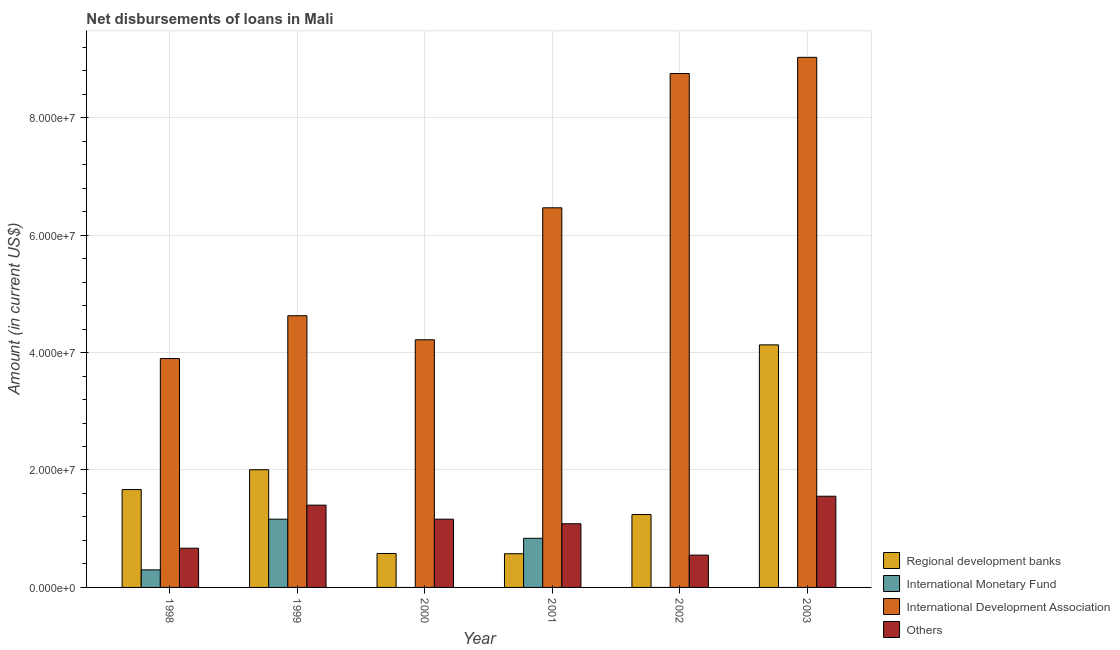How many different coloured bars are there?
Your answer should be very brief. 4. How many groups of bars are there?
Your answer should be compact. 6. Are the number of bars on each tick of the X-axis equal?
Give a very brief answer. No. How many bars are there on the 4th tick from the right?
Provide a succinct answer. 3. In how many cases, is the number of bars for a given year not equal to the number of legend labels?
Ensure brevity in your answer.  3. What is the amount of loan disimbursed by regional development banks in 2003?
Your response must be concise. 4.13e+07. Across all years, what is the maximum amount of loan disimbursed by other organisations?
Provide a short and direct response. 1.55e+07. Across all years, what is the minimum amount of loan disimbursed by international monetary fund?
Your answer should be very brief. 0. In which year was the amount of loan disimbursed by other organisations maximum?
Make the answer very short. 2003. What is the total amount of loan disimbursed by regional development banks in the graph?
Make the answer very short. 1.02e+08. What is the difference between the amount of loan disimbursed by regional development banks in 2000 and that in 2003?
Give a very brief answer. -3.55e+07. What is the difference between the amount of loan disimbursed by regional development banks in 2001 and the amount of loan disimbursed by other organisations in 2000?
Provide a short and direct response. -3.80e+04. What is the average amount of loan disimbursed by international development association per year?
Give a very brief answer. 6.16e+07. What is the ratio of the amount of loan disimbursed by regional development banks in 1998 to that in 1999?
Your response must be concise. 0.83. Is the difference between the amount of loan disimbursed by international monetary fund in 1998 and 1999 greater than the difference between the amount of loan disimbursed by international development association in 1998 and 1999?
Offer a terse response. No. What is the difference between the highest and the second highest amount of loan disimbursed by international development association?
Keep it short and to the point. 2.76e+06. What is the difference between the highest and the lowest amount of loan disimbursed by international monetary fund?
Provide a short and direct response. 1.16e+07. In how many years, is the amount of loan disimbursed by international monetary fund greater than the average amount of loan disimbursed by international monetary fund taken over all years?
Make the answer very short. 2. Is it the case that in every year, the sum of the amount of loan disimbursed by regional development banks and amount of loan disimbursed by international monetary fund is greater than the sum of amount of loan disimbursed by international development association and amount of loan disimbursed by other organisations?
Give a very brief answer. No. Is it the case that in every year, the sum of the amount of loan disimbursed by regional development banks and amount of loan disimbursed by international monetary fund is greater than the amount of loan disimbursed by international development association?
Provide a short and direct response. No. How many bars are there?
Ensure brevity in your answer.  21. Are all the bars in the graph horizontal?
Make the answer very short. No. How many years are there in the graph?
Keep it short and to the point. 6. What is the difference between two consecutive major ticks on the Y-axis?
Keep it short and to the point. 2.00e+07. Are the values on the major ticks of Y-axis written in scientific E-notation?
Give a very brief answer. Yes. Does the graph contain grids?
Your response must be concise. Yes. What is the title of the graph?
Give a very brief answer. Net disbursements of loans in Mali. What is the Amount (in current US$) of Regional development banks in 1998?
Provide a succinct answer. 1.67e+07. What is the Amount (in current US$) of International Monetary Fund in 1998?
Your response must be concise. 2.99e+06. What is the Amount (in current US$) of International Development Association in 1998?
Provide a short and direct response. 3.90e+07. What is the Amount (in current US$) of Others in 1998?
Your answer should be compact. 6.68e+06. What is the Amount (in current US$) of Regional development banks in 1999?
Offer a terse response. 2.00e+07. What is the Amount (in current US$) in International Monetary Fund in 1999?
Give a very brief answer. 1.16e+07. What is the Amount (in current US$) in International Development Association in 1999?
Your answer should be compact. 4.63e+07. What is the Amount (in current US$) of Others in 1999?
Give a very brief answer. 1.40e+07. What is the Amount (in current US$) in Regional development banks in 2000?
Your answer should be very brief. 5.78e+06. What is the Amount (in current US$) in International Monetary Fund in 2000?
Provide a short and direct response. 0. What is the Amount (in current US$) of International Development Association in 2000?
Give a very brief answer. 4.22e+07. What is the Amount (in current US$) of Others in 2000?
Your answer should be very brief. 1.16e+07. What is the Amount (in current US$) in Regional development banks in 2001?
Your response must be concise. 5.74e+06. What is the Amount (in current US$) of International Monetary Fund in 2001?
Offer a terse response. 8.37e+06. What is the Amount (in current US$) of International Development Association in 2001?
Your response must be concise. 6.46e+07. What is the Amount (in current US$) in Others in 2001?
Offer a very short reply. 1.08e+07. What is the Amount (in current US$) in Regional development banks in 2002?
Offer a very short reply. 1.24e+07. What is the Amount (in current US$) of International Development Association in 2002?
Make the answer very short. 8.75e+07. What is the Amount (in current US$) in Others in 2002?
Your answer should be compact. 5.50e+06. What is the Amount (in current US$) in Regional development banks in 2003?
Make the answer very short. 4.13e+07. What is the Amount (in current US$) of International Monetary Fund in 2003?
Provide a succinct answer. 0. What is the Amount (in current US$) of International Development Association in 2003?
Provide a succinct answer. 9.03e+07. What is the Amount (in current US$) of Others in 2003?
Provide a succinct answer. 1.55e+07. Across all years, what is the maximum Amount (in current US$) in Regional development banks?
Your response must be concise. 4.13e+07. Across all years, what is the maximum Amount (in current US$) of International Monetary Fund?
Your response must be concise. 1.16e+07. Across all years, what is the maximum Amount (in current US$) in International Development Association?
Ensure brevity in your answer.  9.03e+07. Across all years, what is the maximum Amount (in current US$) in Others?
Keep it short and to the point. 1.55e+07. Across all years, what is the minimum Amount (in current US$) in Regional development banks?
Your answer should be compact. 5.74e+06. Across all years, what is the minimum Amount (in current US$) of International Monetary Fund?
Offer a terse response. 0. Across all years, what is the minimum Amount (in current US$) of International Development Association?
Provide a short and direct response. 3.90e+07. Across all years, what is the minimum Amount (in current US$) of Others?
Offer a very short reply. 5.50e+06. What is the total Amount (in current US$) of Regional development banks in the graph?
Keep it short and to the point. 1.02e+08. What is the total Amount (in current US$) in International Monetary Fund in the graph?
Make the answer very short. 2.30e+07. What is the total Amount (in current US$) in International Development Association in the graph?
Ensure brevity in your answer.  3.70e+08. What is the total Amount (in current US$) in Others in the graph?
Your answer should be compact. 6.42e+07. What is the difference between the Amount (in current US$) of Regional development banks in 1998 and that in 1999?
Your answer should be very brief. -3.38e+06. What is the difference between the Amount (in current US$) of International Monetary Fund in 1998 and that in 1999?
Offer a terse response. -8.63e+06. What is the difference between the Amount (in current US$) of International Development Association in 1998 and that in 1999?
Provide a succinct answer. -7.29e+06. What is the difference between the Amount (in current US$) in Others in 1998 and that in 1999?
Provide a succinct answer. -7.33e+06. What is the difference between the Amount (in current US$) of Regional development banks in 1998 and that in 2000?
Offer a very short reply. 1.09e+07. What is the difference between the Amount (in current US$) in International Development Association in 1998 and that in 2000?
Your answer should be compact. -3.20e+06. What is the difference between the Amount (in current US$) in Others in 1998 and that in 2000?
Your answer should be compact. -4.94e+06. What is the difference between the Amount (in current US$) in Regional development banks in 1998 and that in 2001?
Keep it short and to the point. 1.09e+07. What is the difference between the Amount (in current US$) of International Monetary Fund in 1998 and that in 2001?
Provide a short and direct response. -5.37e+06. What is the difference between the Amount (in current US$) of International Development Association in 1998 and that in 2001?
Make the answer very short. -2.57e+07. What is the difference between the Amount (in current US$) of Others in 1998 and that in 2001?
Offer a very short reply. -4.16e+06. What is the difference between the Amount (in current US$) of Regional development banks in 1998 and that in 2002?
Your response must be concise. 4.25e+06. What is the difference between the Amount (in current US$) of International Development Association in 1998 and that in 2002?
Give a very brief answer. -4.85e+07. What is the difference between the Amount (in current US$) of Others in 1998 and that in 2002?
Your answer should be very brief. 1.18e+06. What is the difference between the Amount (in current US$) of Regional development banks in 1998 and that in 2003?
Make the answer very short. -2.46e+07. What is the difference between the Amount (in current US$) of International Development Association in 1998 and that in 2003?
Your answer should be very brief. -5.13e+07. What is the difference between the Amount (in current US$) of Others in 1998 and that in 2003?
Provide a succinct answer. -8.85e+06. What is the difference between the Amount (in current US$) in Regional development banks in 1999 and that in 2000?
Make the answer very short. 1.43e+07. What is the difference between the Amount (in current US$) of International Development Association in 1999 and that in 2000?
Make the answer very short. 4.10e+06. What is the difference between the Amount (in current US$) of Others in 1999 and that in 2000?
Your response must be concise. 2.39e+06. What is the difference between the Amount (in current US$) of Regional development banks in 1999 and that in 2001?
Provide a short and direct response. 1.43e+07. What is the difference between the Amount (in current US$) of International Monetary Fund in 1999 and that in 2001?
Offer a terse response. 3.26e+06. What is the difference between the Amount (in current US$) of International Development Association in 1999 and that in 2001?
Your answer should be compact. -1.84e+07. What is the difference between the Amount (in current US$) of Others in 1999 and that in 2001?
Keep it short and to the point. 3.17e+06. What is the difference between the Amount (in current US$) in Regional development banks in 1999 and that in 2002?
Keep it short and to the point. 7.63e+06. What is the difference between the Amount (in current US$) in International Development Association in 1999 and that in 2002?
Your answer should be very brief. -4.12e+07. What is the difference between the Amount (in current US$) of Others in 1999 and that in 2002?
Offer a terse response. 8.51e+06. What is the difference between the Amount (in current US$) of Regional development banks in 1999 and that in 2003?
Keep it short and to the point. -2.13e+07. What is the difference between the Amount (in current US$) of International Development Association in 1999 and that in 2003?
Make the answer very short. -4.40e+07. What is the difference between the Amount (in current US$) of Others in 1999 and that in 2003?
Your answer should be compact. -1.52e+06. What is the difference between the Amount (in current US$) of Regional development banks in 2000 and that in 2001?
Offer a terse response. 3.80e+04. What is the difference between the Amount (in current US$) of International Development Association in 2000 and that in 2001?
Give a very brief answer. -2.25e+07. What is the difference between the Amount (in current US$) in Others in 2000 and that in 2001?
Provide a short and direct response. 7.78e+05. What is the difference between the Amount (in current US$) of Regional development banks in 2000 and that in 2002?
Provide a succinct answer. -6.64e+06. What is the difference between the Amount (in current US$) of International Development Association in 2000 and that in 2002?
Give a very brief answer. -4.53e+07. What is the difference between the Amount (in current US$) of Others in 2000 and that in 2002?
Your response must be concise. 6.12e+06. What is the difference between the Amount (in current US$) in Regional development banks in 2000 and that in 2003?
Provide a succinct answer. -3.55e+07. What is the difference between the Amount (in current US$) of International Development Association in 2000 and that in 2003?
Provide a short and direct response. -4.81e+07. What is the difference between the Amount (in current US$) of Others in 2000 and that in 2003?
Your response must be concise. -3.91e+06. What is the difference between the Amount (in current US$) in Regional development banks in 2001 and that in 2002?
Give a very brief answer. -6.68e+06. What is the difference between the Amount (in current US$) in International Development Association in 2001 and that in 2002?
Your answer should be very brief. -2.29e+07. What is the difference between the Amount (in current US$) in Others in 2001 and that in 2002?
Ensure brevity in your answer.  5.34e+06. What is the difference between the Amount (in current US$) of Regional development banks in 2001 and that in 2003?
Ensure brevity in your answer.  -3.56e+07. What is the difference between the Amount (in current US$) in International Development Association in 2001 and that in 2003?
Keep it short and to the point. -2.56e+07. What is the difference between the Amount (in current US$) in Others in 2001 and that in 2003?
Keep it short and to the point. -4.69e+06. What is the difference between the Amount (in current US$) in Regional development banks in 2002 and that in 2003?
Provide a succinct answer. -2.89e+07. What is the difference between the Amount (in current US$) of International Development Association in 2002 and that in 2003?
Keep it short and to the point. -2.76e+06. What is the difference between the Amount (in current US$) in Others in 2002 and that in 2003?
Keep it short and to the point. -1.00e+07. What is the difference between the Amount (in current US$) in Regional development banks in 1998 and the Amount (in current US$) in International Monetary Fund in 1999?
Ensure brevity in your answer.  5.04e+06. What is the difference between the Amount (in current US$) in Regional development banks in 1998 and the Amount (in current US$) in International Development Association in 1999?
Offer a terse response. -2.96e+07. What is the difference between the Amount (in current US$) in Regional development banks in 1998 and the Amount (in current US$) in Others in 1999?
Provide a succinct answer. 2.65e+06. What is the difference between the Amount (in current US$) of International Monetary Fund in 1998 and the Amount (in current US$) of International Development Association in 1999?
Your answer should be compact. -4.33e+07. What is the difference between the Amount (in current US$) in International Monetary Fund in 1998 and the Amount (in current US$) in Others in 1999?
Give a very brief answer. -1.10e+07. What is the difference between the Amount (in current US$) in International Development Association in 1998 and the Amount (in current US$) in Others in 1999?
Your answer should be very brief. 2.50e+07. What is the difference between the Amount (in current US$) of Regional development banks in 1998 and the Amount (in current US$) of International Development Association in 2000?
Your response must be concise. -2.55e+07. What is the difference between the Amount (in current US$) in Regional development banks in 1998 and the Amount (in current US$) in Others in 2000?
Your response must be concise. 5.04e+06. What is the difference between the Amount (in current US$) of International Monetary Fund in 1998 and the Amount (in current US$) of International Development Association in 2000?
Your answer should be very brief. -3.92e+07. What is the difference between the Amount (in current US$) of International Monetary Fund in 1998 and the Amount (in current US$) of Others in 2000?
Provide a succinct answer. -8.63e+06. What is the difference between the Amount (in current US$) in International Development Association in 1998 and the Amount (in current US$) in Others in 2000?
Keep it short and to the point. 2.74e+07. What is the difference between the Amount (in current US$) of Regional development banks in 1998 and the Amount (in current US$) of International Monetary Fund in 2001?
Ensure brevity in your answer.  8.30e+06. What is the difference between the Amount (in current US$) in Regional development banks in 1998 and the Amount (in current US$) in International Development Association in 2001?
Your response must be concise. -4.80e+07. What is the difference between the Amount (in current US$) of Regional development banks in 1998 and the Amount (in current US$) of Others in 2001?
Give a very brief answer. 5.82e+06. What is the difference between the Amount (in current US$) in International Monetary Fund in 1998 and the Amount (in current US$) in International Development Association in 2001?
Make the answer very short. -6.17e+07. What is the difference between the Amount (in current US$) in International Monetary Fund in 1998 and the Amount (in current US$) in Others in 2001?
Your answer should be very brief. -7.85e+06. What is the difference between the Amount (in current US$) in International Development Association in 1998 and the Amount (in current US$) in Others in 2001?
Keep it short and to the point. 2.81e+07. What is the difference between the Amount (in current US$) in Regional development banks in 1998 and the Amount (in current US$) in International Development Association in 2002?
Your response must be concise. -7.08e+07. What is the difference between the Amount (in current US$) of Regional development banks in 1998 and the Amount (in current US$) of Others in 2002?
Ensure brevity in your answer.  1.12e+07. What is the difference between the Amount (in current US$) in International Monetary Fund in 1998 and the Amount (in current US$) in International Development Association in 2002?
Provide a succinct answer. -8.45e+07. What is the difference between the Amount (in current US$) in International Monetary Fund in 1998 and the Amount (in current US$) in Others in 2002?
Your answer should be very brief. -2.51e+06. What is the difference between the Amount (in current US$) in International Development Association in 1998 and the Amount (in current US$) in Others in 2002?
Your answer should be compact. 3.35e+07. What is the difference between the Amount (in current US$) of Regional development banks in 1998 and the Amount (in current US$) of International Development Association in 2003?
Provide a succinct answer. -7.36e+07. What is the difference between the Amount (in current US$) in Regional development banks in 1998 and the Amount (in current US$) in Others in 2003?
Your answer should be compact. 1.14e+06. What is the difference between the Amount (in current US$) of International Monetary Fund in 1998 and the Amount (in current US$) of International Development Association in 2003?
Ensure brevity in your answer.  -8.73e+07. What is the difference between the Amount (in current US$) in International Monetary Fund in 1998 and the Amount (in current US$) in Others in 2003?
Give a very brief answer. -1.25e+07. What is the difference between the Amount (in current US$) of International Development Association in 1998 and the Amount (in current US$) of Others in 2003?
Give a very brief answer. 2.34e+07. What is the difference between the Amount (in current US$) of Regional development banks in 1999 and the Amount (in current US$) of International Development Association in 2000?
Provide a succinct answer. -2.21e+07. What is the difference between the Amount (in current US$) of Regional development banks in 1999 and the Amount (in current US$) of Others in 2000?
Provide a short and direct response. 8.42e+06. What is the difference between the Amount (in current US$) in International Monetary Fund in 1999 and the Amount (in current US$) in International Development Association in 2000?
Keep it short and to the point. -3.06e+07. What is the difference between the Amount (in current US$) in International Development Association in 1999 and the Amount (in current US$) in Others in 2000?
Give a very brief answer. 3.46e+07. What is the difference between the Amount (in current US$) of Regional development banks in 1999 and the Amount (in current US$) of International Monetary Fund in 2001?
Give a very brief answer. 1.17e+07. What is the difference between the Amount (in current US$) of Regional development banks in 1999 and the Amount (in current US$) of International Development Association in 2001?
Your answer should be very brief. -4.46e+07. What is the difference between the Amount (in current US$) in Regional development banks in 1999 and the Amount (in current US$) in Others in 2001?
Ensure brevity in your answer.  9.20e+06. What is the difference between the Amount (in current US$) in International Monetary Fund in 1999 and the Amount (in current US$) in International Development Association in 2001?
Make the answer very short. -5.30e+07. What is the difference between the Amount (in current US$) in International Monetary Fund in 1999 and the Amount (in current US$) in Others in 2001?
Provide a succinct answer. 7.80e+05. What is the difference between the Amount (in current US$) of International Development Association in 1999 and the Amount (in current US$) of Others in 2001?
Provide a short and direct response. 3.54e+07. What is the difference between the Amount (in current US$) in Regional development banks in 1999 and the Amount (in current US$) in International Development Association in 2002?
Ensure brevity in your answer.  -6.75e+07. What is the difference between the Amount (in current US$) in Regional development banks in 1999 and the Amount (in current US$) in Others in 2002?
Your answer should be very brief. 1.45e+07. What is the difference between the Amount (in current US$) in International Monetary Fund in 1999 and the Amount (in current US$) in International Development Association in 2002?
Keep it short and to the point. -7.59e+07. What is the difference between the Amount (in current US$) of International Monetary Fund in 1999 and the Amount (in current US$) of Others in 2002?
Your response must be concise. 6.12e+06. What is the difference between the Amount (in current US$) of International Development Association in 1999 and the Amount (in current US$) of Others in 2002?
Your response must be concise. 4.08e+07. What is the difference between the Amount (in current US$) in Regional development banks in 1999 and the Amount (in current US$) in International Development Association in 2003?
Make the answer very short. -7.02e+07. What is the difference between the Amount (in current US$) in Regional development banks in 1999 and the Amount (in current US$) in Others in 2003?
Make the answer very short. 4.51e+06. What is the difference between the Amount (in current US$) of International Monetary Fund in 1999 and the Amount (in current US$) of International Development Association in 2003?
Your answer should be compact. -7.86e+07. What is the difference between the Amount (in current US$) in International Monetary Fund in 1999 and the Amount (in current US$) in Others in 2003?
Your answer should be compact. -3.91e+06. What is the difference between the Amount (in current US$) of International Development Association in 1999 and the Amount (in current US$) of Others in 2003?
Your answer should be compact. 3.07e+07. What is the difference between the Amount (in current US$) in Regional development banks in 2000 and the Amount (in current US$) in International Monetary Fund in 2001?
Your response must be concise. -2.59e+06. What is the difference between the Amount (in current US$) in Regional development banks in 2000 and the Amount (in current US$) in International Development Association in 2001?
Offer a terse response. -5.89e+07. What is the difference between the Amount (in current US$) in Regional development banks in 2000 and the Amount (in current US$) in Others in 2001?
Your answer should be compact. -5.07e+06. What is the difference between the Amount (in current US$) of International Development Association in 2000 and the Amount (in current US$) of Others in 2001?
Keep it short and to the point. 3.13e+07. What is the difference between the Amount (in current US$) of Regional development banks in 2000 and the Amount (in current US$) of International Development Association in 2002?
Make the answer very short. -8.17e+07. What is the difference between the Amount (in current US$) of Regional development banks in 2000 and the Amount (in current US$) of Others in 2002?
Provide a succinct answer. 2.74e+05. What is the difference between the Amount (in current US$) in International Development Association in 2000 and the Amount (in current US$) in Others in 2002?
Your answer should be compact. 3.67e+07. What is the difference between the Amount (in current US$) in Regional development banks in 2000 and the Amount (in current US$) in International Development Association in 2003?
Keep it short and to the point. -8.45e+07. What is the difference between the Amount (in current US$) in Regional development banks in 2000 and the Amount (in current US$) in Others in 2003?
Your response must be concise. -9.76e+06. What is the difference between the Amount (in current US$) of International Development Association in 2000 and the Amount (in current US$) of Others in 2003?
Your response must be concise. 2.66e+07. What is the difference between the Amount (in current US$) of Regional development banks in 2001 and the Amount (in current US$) of International Development Association in 2002?
Offer a terse response. -8.18e+07. What is the difference between the Amount (in current US$) in Regional development banks in 2001 and the Amount (in current US$) in Others in 2002?
Keep it short and to the point. 2.36e+05. What is the difference between the Amount (in current US$) of International Monetary Fund in 2001 and the Amount (in current US$) of International Development Association in 2002?
Ensure brevity in your answer.  -7.91e+07. What is the difference between the Amount (in current US$) of International Monetary Fund in 2001 and the Amount (in current US$) of Others in 2002?
Offer a terse response. 2.87e+06. What is the difference between the Amount (in current US$) of International Development Association in 2001 and the Amount (in current US$) of Others in 2002?
Your answer should be very brief. 5.91e+07. What is the difference between the Amount (in current US$) in Regional development banks in 2001 and the Amount (in current US$) in International Development Association in 2003?
Provide a succinct answer. -8.45e+07. What is the difference between the Amount (in current US$) of Regional development banks in 2001 and the Amount (in current US$) of Others in 2003?
Give a very brief answer. -9.79e+06. What is the difference between the Amount (in current US$) in International Monetary Fund in 2001 and the Amount (in current US$) in International Development Association in 2003?
Your answer should be compact. -8.19e+07. What is the difference between the Amount (in current US$) in International Monetary Fund in 2001 and the Amount (in current US$) in Others in 2003?
Provide a succinct answer. -7.16e+06. What is the difference between the Amount (in current US$) of International Development Association in 2001 and the Amount (in current US$) of Others in 2003?
Keep it short and to the point. 4.91e+07. What is the difference between the Amount (in current US$) in Regional development banks in 2002 and the Amount (in current US$) in International Development Association in 2003?
Your answer should be compact. -7.79e+07. What is the difference between the Amount (in current US$) of Regional development banks in 2002 and the Amount (in current US$) of Others in 2003?
Provide a short and direct response. -3.12e+06. What is the difference between the Amount (in current US$) of International Development Association in 2002 and the Amount (in current US$) of Others in 2003?
Provide a short and direct response. 7.20e+07. What is the average Amount (in current US$) of Regional development banks per year?
Offer a terse response. 1.70e+07. What is the average Amount (in current US$) of International Monetary Fund per year?
Your response must be concise. 3.83e+06. What is the average Amount (in current US$) in International Development Association per year?
Keep it short and to the point. 6.16e+07. What is the average Amount (in current US$) of Others per year?
Offer a terse response. 1.07e+07. In the year 1998, what is the difference between the Amount (in current US$) in Regional development banks and Amount (in current US$) in International Monetary Fund?
Your answer should be very brief. 1.37e+07. In the year 1998, what is the difference between the Amount (in current US$) of Regional development banks and Amount (in current US$) of International Development Association?
Your response must be concise. -2.23e+07. In the year 1998, what is the difference between the Amount (in current US$) of Regional development banks and Amount (in current US$) of Others?
Your answer should be very brief. 9.99e+06. In the year 1998, what is the difference between the Amount (in current US$) in International Monetary Fund and Amount (in current US$) in International Development Association?
Your answer should be compact. -3.60e+07. In the year 1998, what is the difference between the Amount (in current US$) in International Monetary Fund and Amount (in current US$) in Others?
Keep it short and to the point. -3.68e+06. In the year 1998, what is the difference between the Amount (in current US$) of International Development Association and Amount (in current US$) of Others?
Your response must be concise. 3.23e+07. In the year 1999, what is the difference between the Amount (in current US$) of Regional development banks and Amount (in current US$) of International Monetary Fund?
Your response must be concise. 8.42e+06. In the year 1999, what is the difference between the Amount (in current US$) in Regional development banks and Amount (in current US$) in International Development Association?
Offer a terse response. -2.62e+07. In the year 1999, what is the difference between the Amount (in current US$) in Regional development banks and Amount (in current US$) in Others?
Offer a very short reply. 6.03e+06. In the year 1999, what is the difference between the Amount (in current US$) in International Monetary Fund and Amount (in current US$) in International Development Association?
Provide a short and direct response. -3.46e+07. In the year 1999, what is the difference between the Amount (in current US$) of International Monetary Fund and Amount (in current US$) of Others?
Your answer should be very brief. -2.39e+06. In the year 1999, what is the difference between the Amount (in current US$) of International Development Association and Amount (in current US$) of Others?
Ensure brevity in your answer.  3.23e+07. In the year 2000, what is the difference between the Amount (in current US$) in Regional development banks and Amount (in current US$) in International Development Association?
Your answer should be very brief. -3.64e+07. In the year 2000, what is the difference between the Amount (in current US$) in Regional development banks and Amount (in current US$) in Others?
Your answer should be very brief. -5.85e+06. In the year 2000, what is the difference between the Amount (in current US$) in International Development Association and Amount (in current US$) in Others?
Ensure brevity in your answer.  3.06e+07. In the year 2001, what is the difference between the Amount (in current US$) in Regional development banks and Amount (in current US$) in International Monetary Fund?
Offer a very short reply. -2.63e+06. In the year 2001, what is the difference between the Amount (in current US$) in Regional development banks and Amount (in current US$) in International Development Association?
Give a very brief answer. -5.89e+07. In the year 2001, what is the difference between the Amount (in current US$) in Regional development banks and Amount (in current US$) in Others?
Ensure brevity in your answer.  -5.11e+06. In the year 2001, what is the difference between the Amount (in current US$) in International Monetary Fund and Amount (in current US$) in International Development Association?
Give a very brief answer. -5.63e+07. In the year 2001, what is the difference between the Amount (in current US$) in International Monetary Fund and Amount (in current US$) in Others?
Offer a terse response. -2.48e+06. In the year 2001, what is the difference between the Amount (in current US$) in International Development Association and Amount (in current US$) in Others?
Offer a terse response. 5.38e+07. In the year 2002, what is the difference between the Amount (in current US$) in Regional development banks and Amount (in current US$) in International Development Association?
Keep it short and to the point. -7.51e+07. In the year 2002, what is the difference between the Amount (in current US$) of Regional development banks and Amount (in current US$) of Others?
Provide a succinct answer. 6.91e+06. In the year 2002, what is the difference between the Amount (in current US$) in International Development Association and Amount (in current US$) in Others?
Offer a very short reply. 8.20e+07. In the year 2003, what is the difference between the Amount (in current US$) in Regional development banks and Amount (in current US$) in International Development Association?
Give a very brief answer. -4.90e+07. In the year 2003, what is the difference between the Amount (in current US$) in Regional development banks and Amount (in current US$) in Others?
Offer a very short reply. 2.58e+07. In the year 2003, what is the difference between the Amount (in current US$) in International Development Association and Amount (in current US$) in Others?
Offer a very short reply. 7.47e+07. What is the ratio of the Amount (in current US$) in Regional development banks in 1998 to that in 1999?
Provide a short and direct response. 0.83. What is the ratio of the Amount (in current US$) of International Monetary Fund in 1998 to that in 1999?
Offer a terse response. 0.26. What is the ratio of the Amount (in current US$) of International Development Association in 1998 to that in 1999?
Provide a succinct answer. 0.84. What is the ratio of the Amount (in current US$) of Others in 1998 to that in 1999?
Make the answer very short. 0.48. What is the ratio of the Amount (in current US$) of Regional development banks in 1998 to that in 2000?
Your response must be concise. 2.89. What is the ratio of the Amount (in current US$) in International Development Association in 1998 to that in 2000?
Your answer should be very brief. 0.92. What is the ratio of the Amount (in current US$) of Others in 1998 to that in 2000?
Your answer should be compact. 0.57. What is the ratio of the Amount (in current US$) of Regional development banks in 1998 to that in 2001?
Offer a very short reply. 2.9. What is the ratio of the Amount (in current US$) of International Monetary Fund in 1998 to that in 2001?
Keep it short and to the point. 0.36. What is the ratio of the Amount (in current US$) of International Development Association in 1998 to that in 2001?
Give a very brief answer. 0.6. What is the ratio of the Amount (in current US$) in Others in 1998 to that in 2001?
Ensure brevity in your answer.  0.62. What is the ratio of the Amount (in current US$) of Regional development banks in 1998 to that in 2002?
Your response must be concise. 1.34. What is the ratio of the Amount (in current US$) of International Development Association in 1998 to that in 2002?
Make the answer very short. 0.45. What is the ratio of the Amount (in current US$) in Others in 1998 to that in 2002?
Offer a terse response. 1.21. What is the ratio of the Amount (in current US$) in Regional development banks in 1998 to that in 2003?
Provide a short and direct response. 0.4. What is the ratio of the Amount (in current US$) in International Development Association in 1998 to that in 2003?
Give a very brief answer. 0.43. What is the ratio of the Amount (in current US$) in Others in 1998 to that in 2003?
Ensure brevity in your answer.  0.43. What is the ratio of the Amount (in current US$) in Regional development banks in 1999 to that in 2000?
Provide a short and direct response. 3.47. What is the ratio of the Amount (in current US$) in International Development Association in 1999 to that in 2000?
Ensure brevity in your answer.  1.1. What is the ratio of the Amount (in current US$) in Others in 1999 to that in 2000?
Give a very brief answer. 1.21. What is the ratio of the Amount (in current US$) in Regional development banks in 1999 to that in 2001?
Keep it short and to the point. 3.49. What is the ratio of the Amount (in current US$) in International Monetary Fund in 1999 to that in 2001?
Give a very brief answer. 1.39. What is the ratio of the Amount (in current US$) of International Development Association in 1999 to that in 2001?
Offer a terse response. 0.72. What is the ratio of the Amount (in current US$) in Others in 1999 to that in 2001?
Offer a very short reply. 1.29. What is the ratio of the Amount (in current US$) in Regional development banks in 1999 to that in 2002?
Ensure brevity in your answer.  1.61. What is the ratio of the Amount (in current US$) in International Development Association in 1999 to that in 2002?
Give a very brief answer. 0.53. What is the ratio of the Amount (in current US$) in Others in 1999 to that in 2002?
Your answer should be very brief. 2.55. What is the ratio of the Amount (in current US$) of Regional development banks in 1999 to that in 2003?
Provide a short and direct response. 0.49. What is the ratio of the Amount (in current US$) in International Development Association in 1999 to that in 2003?
Offer a terse response. 0.51. What is the ratio of the Amount (in current US$) in Others in 1999 to that in 2003?
Provide a succinct answer. 0.9. What is the ratio of the Amount (in current US$) in Regional development banks in 2000 to that in 2001?
Provide a short and direct response. 1.01. What is the ratio of the Amount (in current US$) in International Development Association in 2000 to that in 2001?
Ensure brevity in your answer.  0.65. What is the ratio of the Amount (in current US$) of Others in 2000 to that in 2001?
Ensure brevity in your answer.  1.07. What is the ratio of the Amount (in current US$) in Regional development banks in 2000 to that in 2002?
Keep it short and to the point. 0.47. What is the ratio of the Amount (in current US$) of International Development Association in 2000 to that in 2002?
Your answer should be very brief. 0.48. What is the ratio of the Amount (in current US$) of Others in 2000 to that in 2002?
Make the answer very short. 2.11. What is the ratio of the Amount (in current US$) in Regional development banks in 2000 to that in 2003?
Make the answer very short. 0.14. What is the ratio of the Amount (in current US$) of International Development Association in 2000 to that in 2003?
Ensure brevity in your answer.  0.47. What is the ratio of the Amount (in current US$) in Others in 2000 to that in 2003?
Your response must be concise. 0.75. What is the ratio of the Amount (in current US$) in Regional development banks in 2001 to that in 2002?
Your answer should be compact. 0.46. What is the ratio of the Amount (in current US$) in International Development Association in 2001 to that in 2002?
Give a very brief answer. 0.74. What is the ratio of the Amount (in current US$) in Others in 2001 to that in 2002?
Provide a succinct answer. 1.97. What is the ratio of the Amount (in current US$) of Regional development banks in 2001 to that in 2003?
Offer a terse response. 0.14. What is the ratio of the Amount (in current US$) of International Development Association in 2001 to that in 2003?
Keep it short and to the point. 0.72. What is the ratio of the Amount (in current US$) of Others in 2001 to that in 2003?
Offer a very short reply. 0.7. What is the ratio of the Amount (in current US$) in Regional development banks in 2002 to that in 2003?
Your answer should be compact. 0.3. What is the ratio of the Amount (in current US$) in International Development Association in 2002 to that in 2003?
Provide a short and direct response. 0.97. What is the ratio of the Amount (in current US$) of Others in 2002 to that in 2003?
Your answer should be very brief. 0.35. What is the difference between the highest and the second highest Amount (in current US$) of Regional development banks?
Provide a succinct answer. 2.13e+07. What is the difference between the highest and the second highest Amount (in current US$) of International Monetary Fund?
Provide a short and direct response. 3.26e+06. What is the difference between the highest and the second highest Amount (in current US$) of International Development Association?
Ensure brevity in your answer.  2.76e+06. What is the difference between the highest and the second highest Amount (in current US$) of Others?
Your answer should be compact. 1.52e+06. What is the difference between the highest and the lowest Amount (in current US$) in Regional development banks?
Your answer should be very brief. 3.56e+07. What is the difference between the highest and the lowest Amount (in current US$) in International Monetary Fund?
Keep it short and to the point. 1.16e+07. What is the difference between the highest and the lowest Amount (in current US$) in International Development Association?
Make the answer very short. 5.13e+07. What is the difference between the highest and the lowest Amount (in current US$) in Others?
Your answer should be compact. 1.00e+07. 